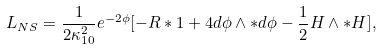<formula> <loc_0><loc_0><loc_500><loc_500>L _ { N S } = \frac { 1 } { 2 \kappa _ { 1 0 } ^ { 2 } } e ^ { - 2 \phi } [ - R * 1 + 4 d \phi \wedge * d \phi - \frac { 1 } { 2 } H \wedge * H ] ,</formula> 